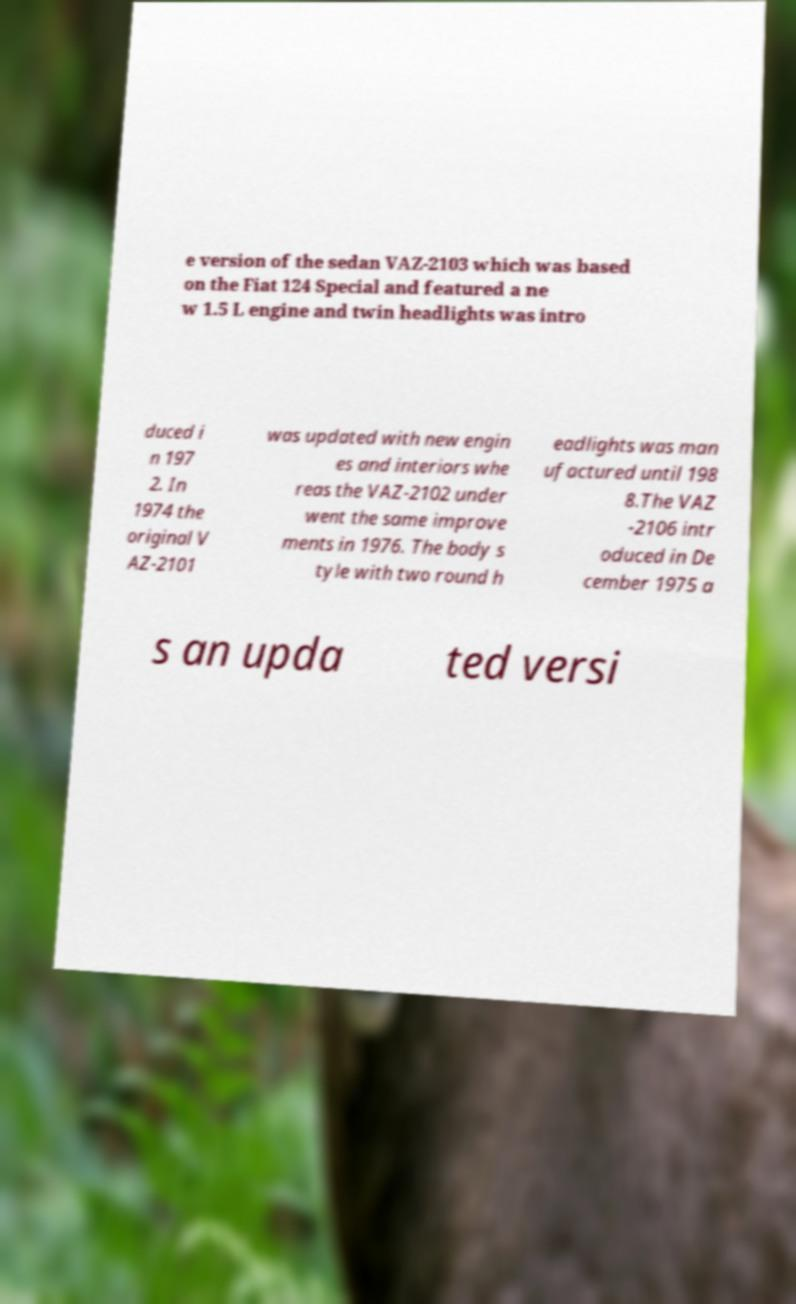What messages or text are displayed in this image? I need them in a readable, typed format. e version of the sedan VAZ-2103 which was based on the Fiat 124 Special and featured a ne w 1.5 L engine and twin headlights was intro duced i n 197 2. In 1974 the original V AZ-2101 was updated with new engin es and interiors whe reas the VAZ-2102 under went the same improve ments in 1976. The body s tyle with two round h eadlights was man ufactured until 198 8.The VAZ -2106 intr oduced in De cember 1975 a s an upda ted versi 